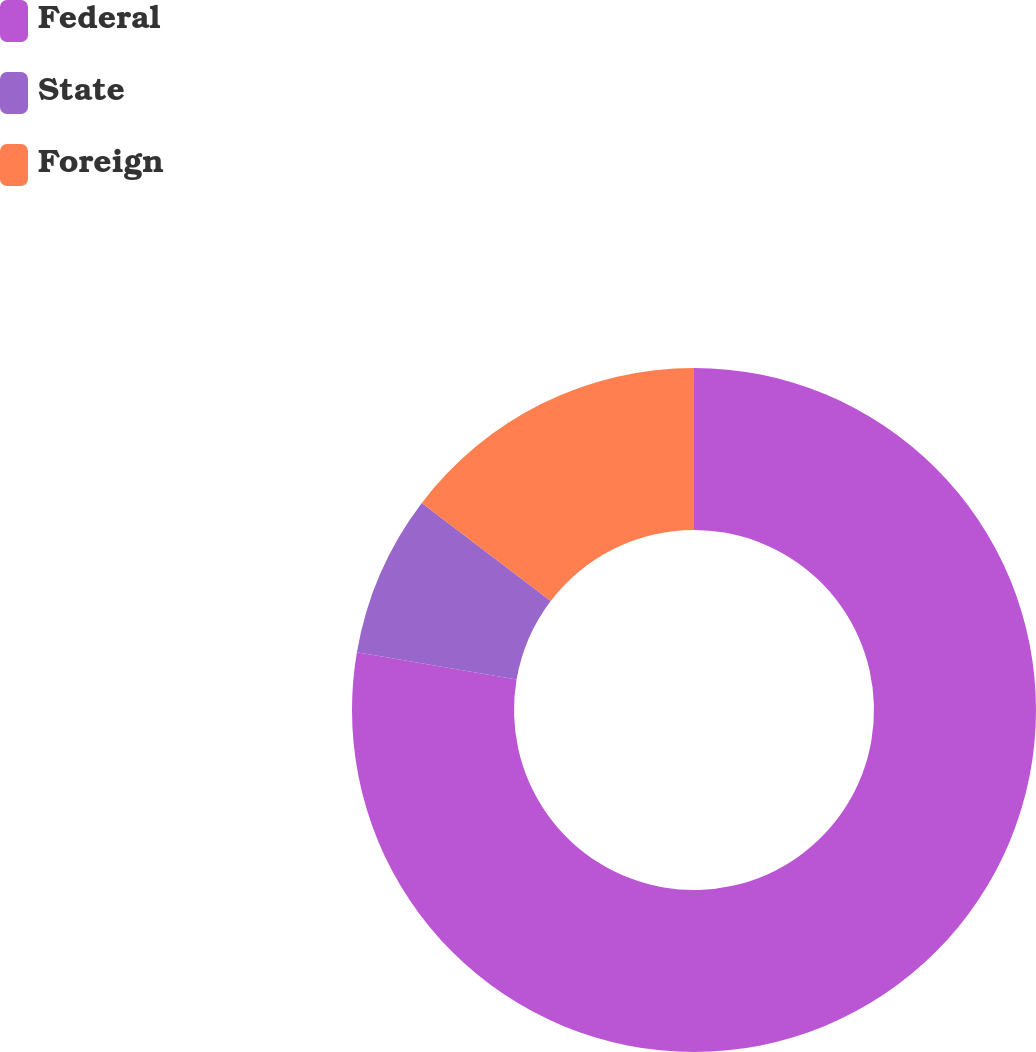Convert chart. <chart><loc_0><loc_0><loc_500><loc_500><pie_chart><fcel>Federal<fcel>State<fcel>Foreign<nl><fcel>77.7%<fcel>7.65%<fcel>14.65%<nl></chart> 